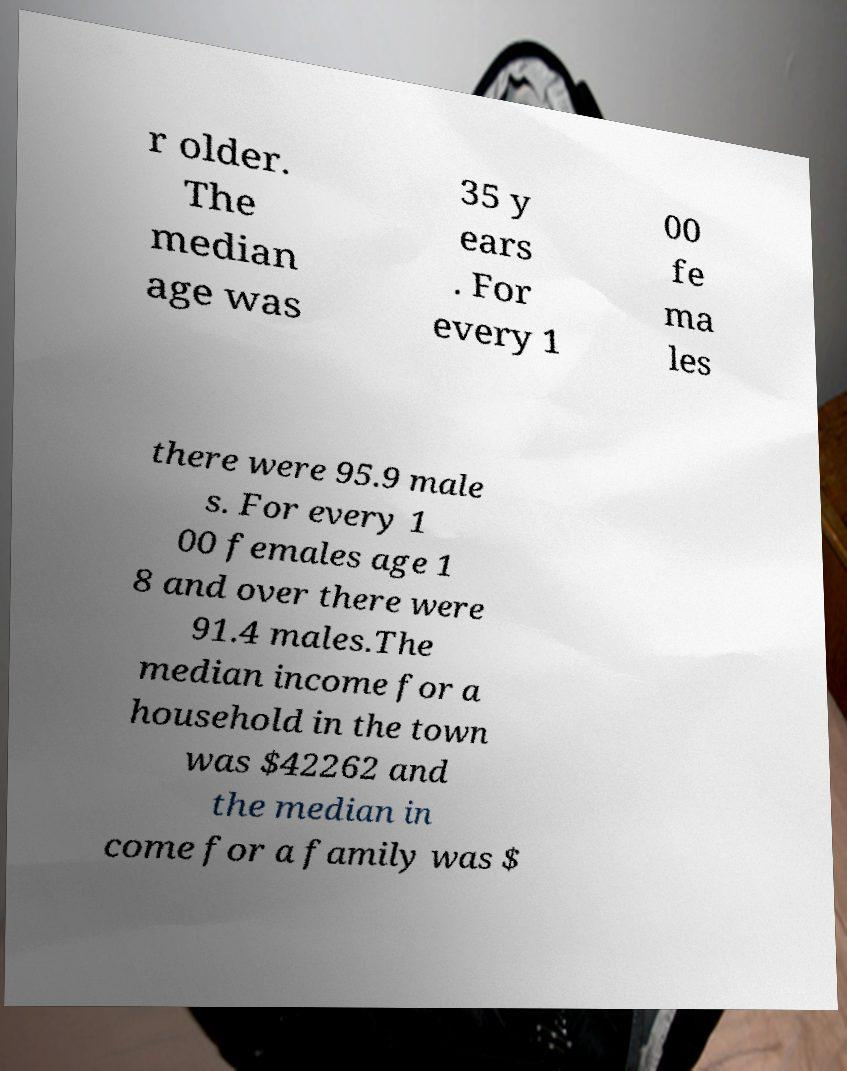I need the written content from this picture converted into text. Can you do that? r older. The median age was 35 y ears . For every 1 00 fe ma les there were 95.9 male s. For every 1 00 females age 1 8 and over there were 91.4 males.The median income for a household in the town was $42262 and the median in come for a family was $ 